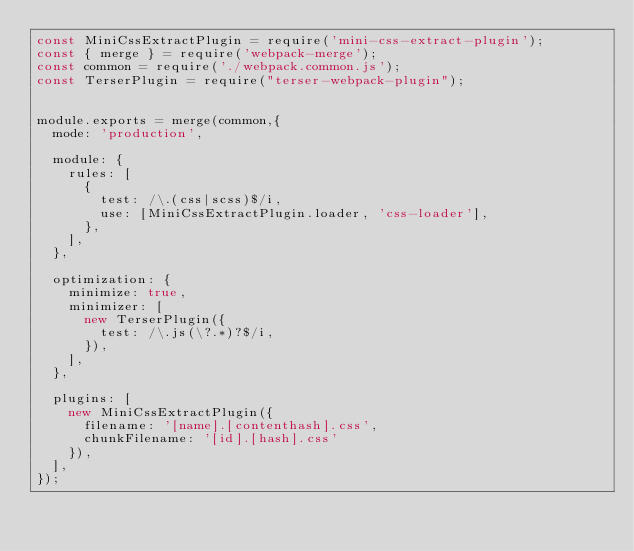Convert code to text. <code><loc_0><loc_0><loc_500><loc_500><_JavaScript_>const MiniCssExtractPlugin = require('mini-css-extract-plugin');
const { merge } = require('webpack-merge');
const common = require('./webpack.common.js');
const TerserPlugin = require("terser-webpack-plugin");


module.exports = merge(common,{
  mode: 'production',

  module: {
    rules: [
      {
        test: /\.(css|scss)$/i,
        use: [MiniCssExtractPlugin.loader, 'css-loader'],
      },
    ],
  },

  optimization: {
    minimize: true,
    minimizer: [
      new TerserPlugin({
        test: /\.js(\?.*)?$/i,
      }),
    ],
  },

  plugins: [
    new MiniCssExtractPlugin({
      filename: '[name].[contenthash].css',
      chunkFilename: '[id].[hash].css'
    }),
  ],
});</code> 